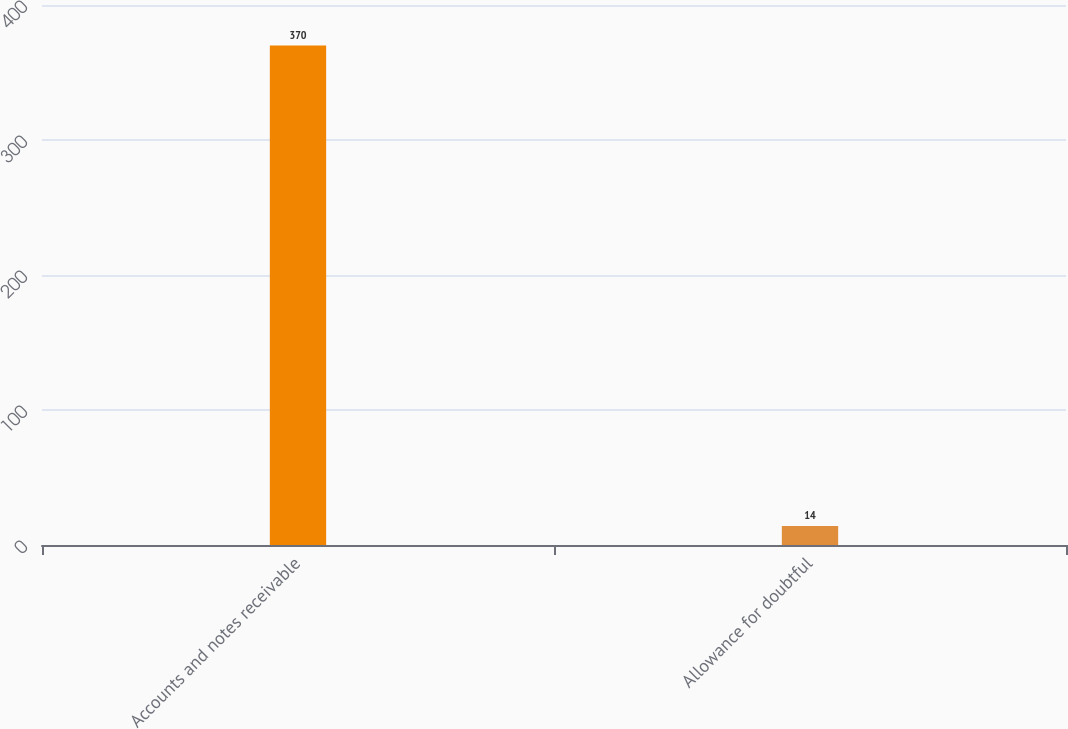<chart> <loc_0><loc_0><loc_500><loc_500><bar_chart><fcel>Accounts and notes receivable<fcel>Allowance for doubtful<nl><fcel>370<fcel>14<nl></chart> 